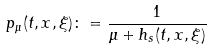<formula> <loc_0><loc_0><loc_500><loc_500>p _ { \mu } ( t , x , \xi ) \colon = \frac { 1 } { \mu + h _ { s } ( t , x , \xi ) }</formula> 